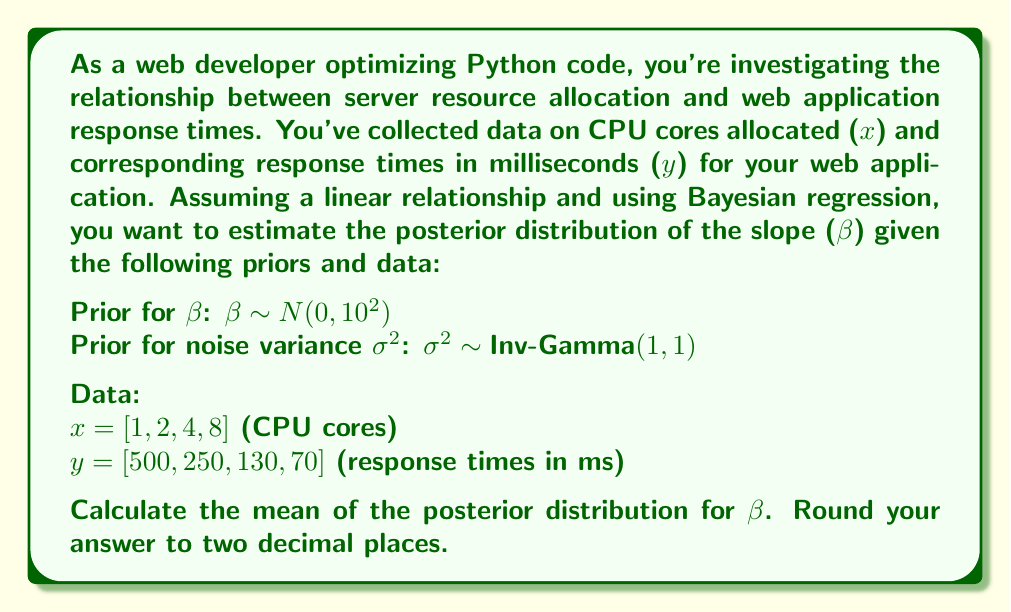Can you answer this question? To solve this problem using Bayesian regression, we'll follow these steps:

1) The model we're using is: $y_i = \beta x_i + \epsilon_i$, where $\epsilon_i \sim N(0, \sigma^2)$

2) The posterior distribution for $\beta$ given the data is proportional to:

   $p(\beta|x,y) \propto p(y|x,\beta) \cdot p(\beta)$

3) For linear regression with known variance, the posterior distribution of $\beta$ is also normal. Its mean is a weighted average of the prior mean and the maximum likelihood estimate (MLE).

4) The posterior mean for $\beta$ is given by:

   $\beta_{post} = \frac{\beta_{prior}/\sigma_{prior}^2 + \beta_{MLE}/\sigma_{MLE}^2}{1/\sigma_{prior}^2 + 1/\sigma_{MLE}^2}$

5) We need to calculate $\beta_{MLE}$ and $\sigma_{MLE}^2$:

   $\beta_{MLE} = \frac{\sum (x_i - \bar{x})(y_i - \bar{y})}{\sum (x_i - \bar{x})^2}$

   $\bar{x} = (1 + 2 + 4 + 8) / 4 = 3.75$
   $\bar{y} = (500 + 250 + 130 + 70) / 4 = 237.5$

   $\beta_{MLE} = \frac{(-2.75 \cdot 262.5 + (-1.75 \cdot 12.5) + (0.25 \cdot -107.5) + (4.25 \cdot -167.5))}{(-2.75)^2 + (-1.75)^2 + (0.25)^2 + (4.25)^2} = -61.81$

6) $\sigma_{MLE}^2$ can be estimated as:

   $\sigma_{MLE}^2 = \frac{\sum (y_i - \beta_{MLE}x_i)^2}{n-2} = 1089.84$

7) Now we can calculate the posterior mean:

   $\beta_{post} = \frac{0/10^2 + (-61.81)/1089.84}{1/10^2 + 1/1089.84} = -60.94$

8) Rounding to two decimal places gives us -60.94.
Answer: $-60.94$ 